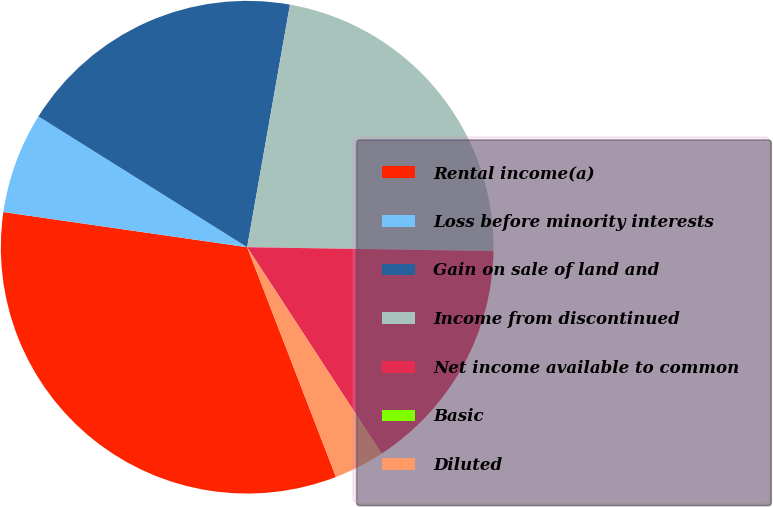Convert chart to OTSL. <chart><loc_0><loc_0><loc_500><loc_500><pie_chart><fcel>Rental income(a)<fcel>Loss before minority interests<fcel>Gain on sale of land and<fcel>Income from discontinued<fcel>Net income available to common<fcel>Basic<fcel>Diluted<nl><fcel>33.15%<fcel>6.63%<fcel>18.87%<fcel>22.47%<fcel>15.56%<fcel>0.0%<fcel>3.32%<nl></chart> 